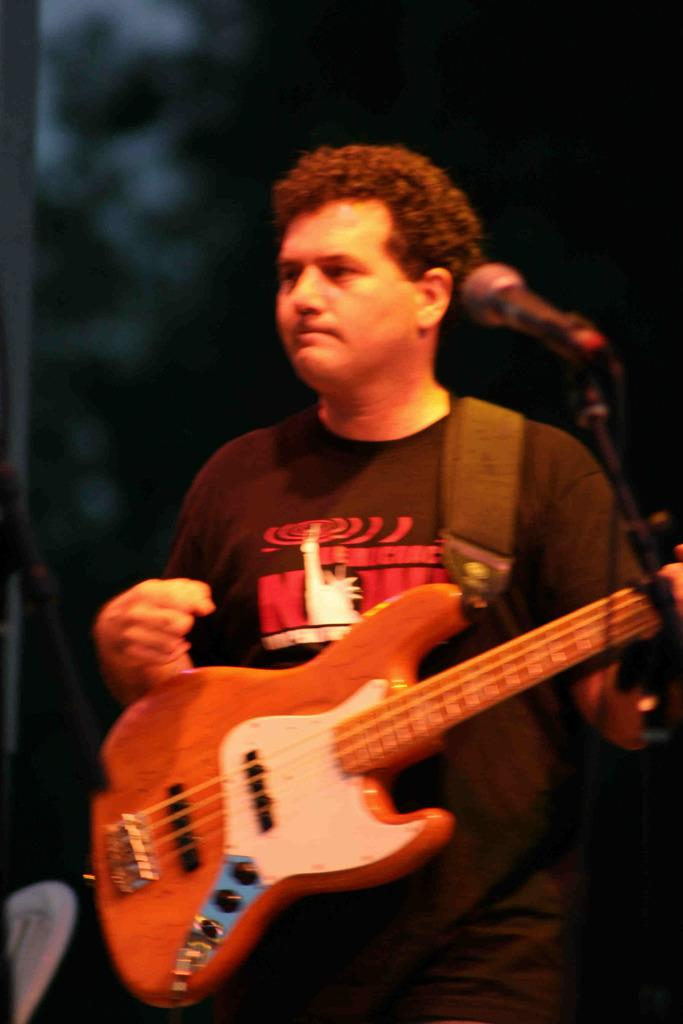What is the main subject of the image? The main subject of the image is a guy. What is the guy holding in the image? The guy is holding a guitar. What other object is present in the image? There is a microphone in the image. Where is the guy positioned in relation to the microphone? The guy is standing in front of the microphone. What type of debt is the guy discussing with his partner in the image? There is no mention of debt or a partner in the image; it features a guy holding a guitar and standing in front of a microphone. Can you tell me how many drums are visible in the image? There are no drums present in the image. 